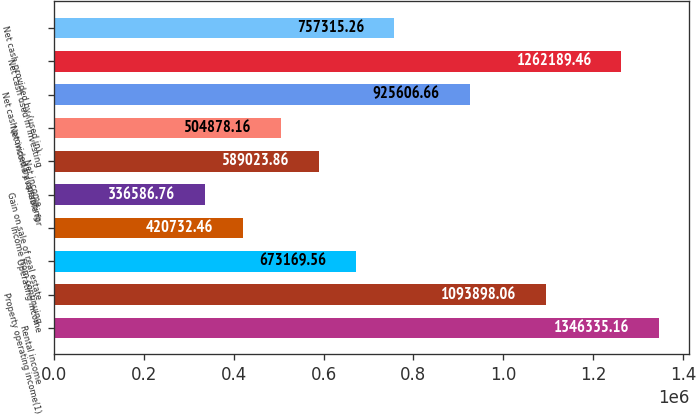Convert chart to OTSL. <chart><loc_0><loc_0><loc_500><loc_500><bar_chart><fcel>Rental income<fcel>Property operating income(1)<fcel>Operating income<fcel>Income from continuing<fcel>Gain on sale of real estate<fcel>Net income<fcel>Net income available for<fcel>Net cash provided by operating<fcel>Net cash used in investing<fcel>Net cash provided by (used in)<nl><fcel>1.34634e+06<fcel>1.0939e+06<fcel>673170<fcel>420732<fcel>336587<fcel>589024<fcel>504878<fcel>925607<fcel>1.26219e+06<fcel>757315<nl></chart> 